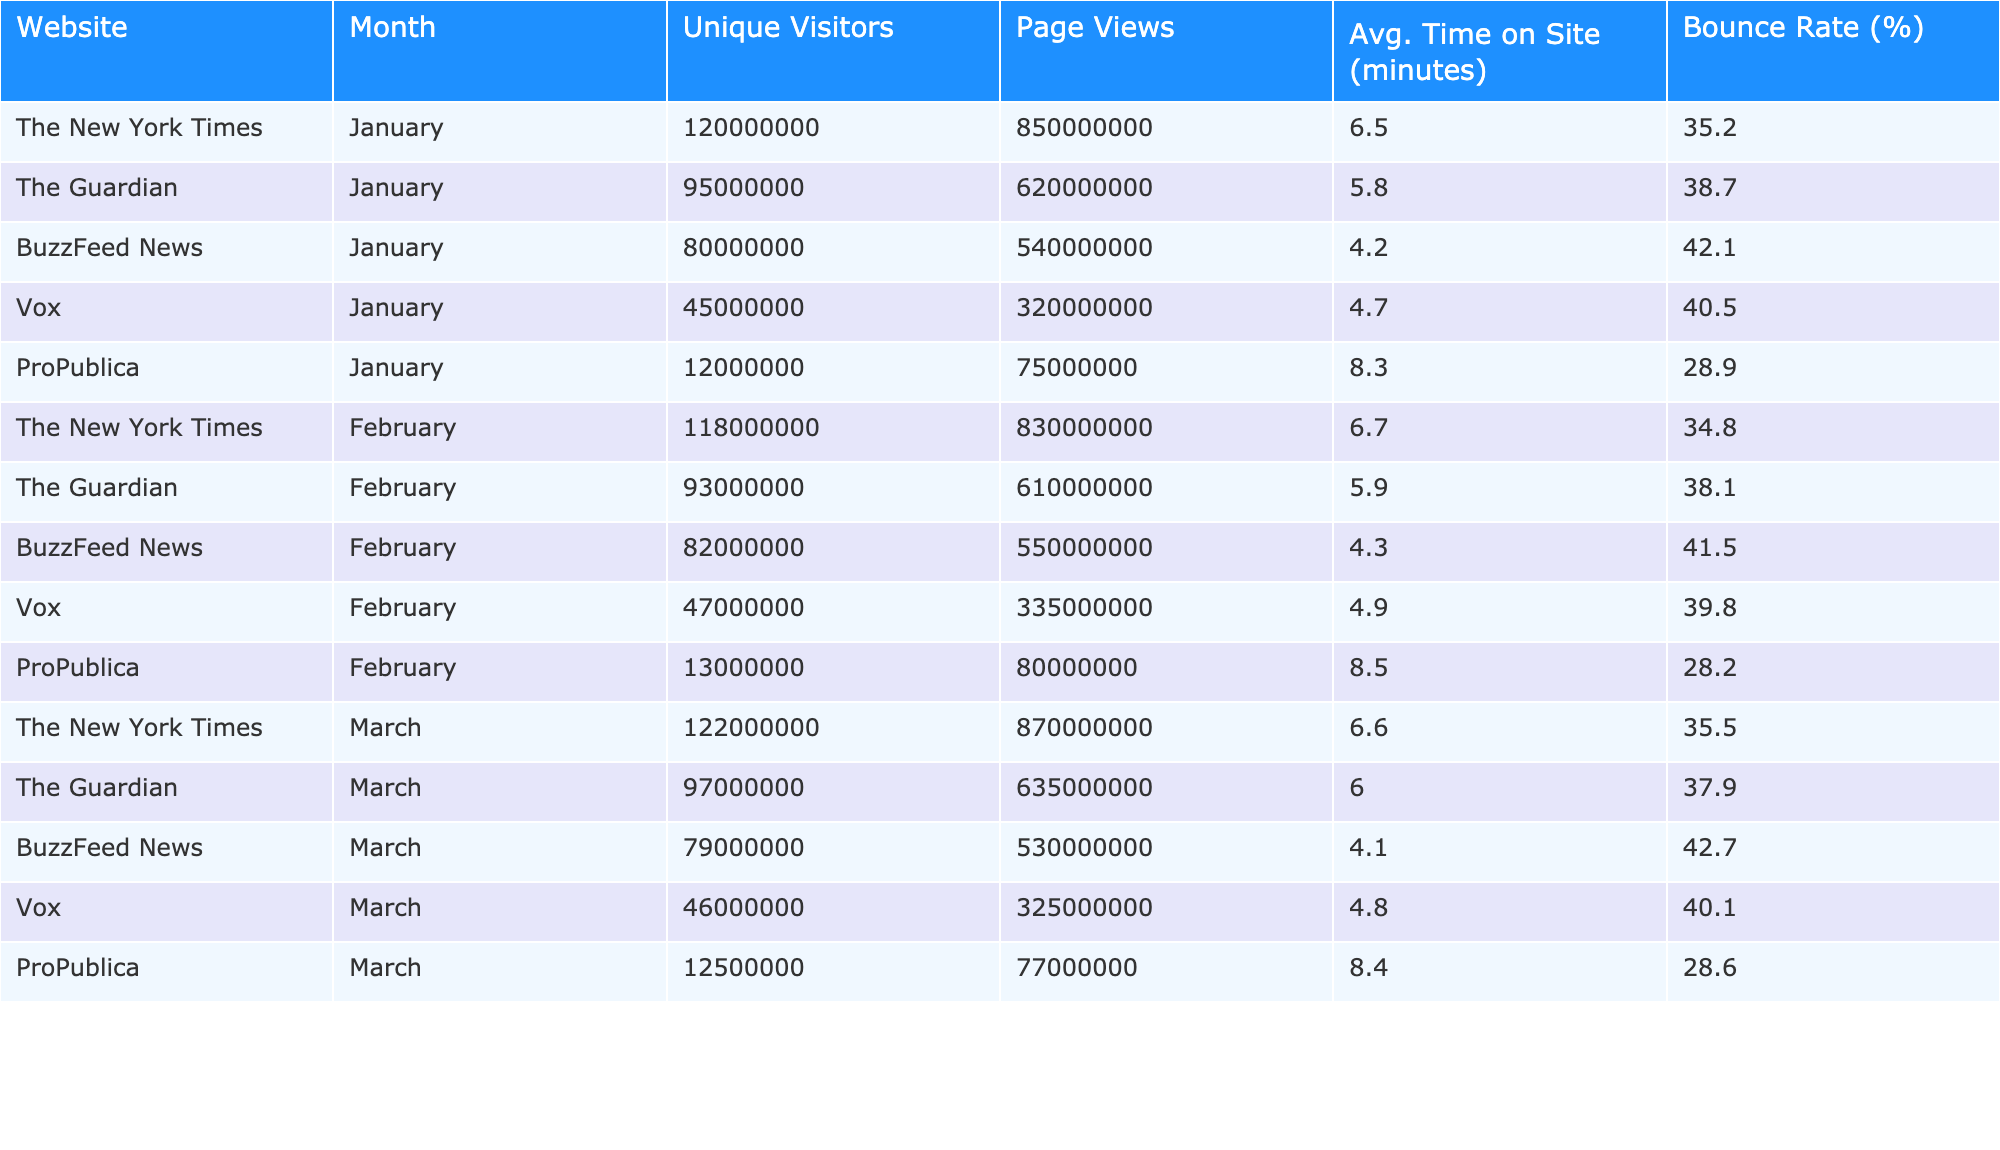What was the total number of unique visitors across all platforms in January? The unique visitors for January are: 120,000,000 (The New York Times) + 95,000,000 (The Guardian) + 80,000,000 (BuzzFeed News) + 45,000,000 (Vox) + 12,000,000 (ProPublica). Summing these gives a total of 120,000,000 + 95,000,000 + 80,000,000 + 45,000,000 + 12,000,000 = 352,000,000.
Answer: 352,000,000 Which platform had the highest average time on site in February? The average times on site for February are: 6.7 minutes (The New York Times), 5.9 minutes (The Guardian), 4.3 minutes (BuzzFeed News), 4.9 minutes (Vox), and 8.5 minutes (ProPublica). ProPublica has the highest average at 8.5 minutes.
Answer: ProPublica What is the bounce rate for BuzzFeed News in March? The bounce rate for BuzzFeed News in March is 42.7%.
Answer: 42.7% Did The Guardian have a decrease in unique visitors from January to February? The unique visitors for The Guardian were 95,000,000 in January and decreased to 93,000,000 in February. Since 93,000,000 is less than 95,000,000, this is true.
Answer: Yes What is the average unique visitors per month for The New York Times? The unique visitors for The New York Times are 120,000,000 (January), 118,000,000 (February), and 122,000,000 (March). The total is 120,000,000 + 118,000,000 + 122,000,000 = 360,000,000. Dividing this by 3 gives an average of 120,000,000.
Answer: 120,000,000 What was the total number of page views for Vox across all three months? The page views for Vox are 320,000,000 (January), 335,000,000 (February), and 325,000,000 (March). Summing these gives 320,000,000 + 335,000,000 + 325,000,000 = 980,000,000.
Answer: 980,000,000 Which platform had the lowest bounce rate in January, and what was that rate? The bounce rates for January are: 35.2% (The New York Times), 38.7% (The Guardian), 42.1% (BuzzFeed News), 40.5% (Vox), and 28.9% (ProPublica). ProPublica had the lowest rate at 28.9%.
Answer: ProPublica, 28.9% Was there an increase in page views for BuzzFeed News from January to February? The page views for BuzzFeed News are 540,000,000 in January and 550,000,000 in February. Since 550,000,000 is greater than 540,000,000, this is true, indicating an increase.
Answer: Yes What are the average bounce rates across all platforms for March? The bounce rates for March are: 35.5% (The New York Times), 37.9% (The Guardian), 42.7% (BuzzFeed News), 40.1% (Vox), and 28.6% (ProPublica). The total is 35.5 + 37.9 + 42.7 + 40.1 + 28.6 = 184.8, dividing by 5 gives an average of 36.96%.
Answer: 36.96% Which platform experienced the most significant drop in unique visitors from January to March? The unique visitors for platforms are: The New York Times (120,000,000 to 122,000,000 shows an increase), The Guardian (95,000,000 to 97,000,000 shows an increase), BuzzFeed News (80,000,000 to 79,000,000 showing a drop of 1,000,000), Vox (45,000,000 to 46,000,000 shows an increase), and ProPublica (12,000,000 to 12,500,000 shows an increase). Hence, BuzzFeed News had the most significant drop at 1,000,000.
Answer: BuzzFeed News 